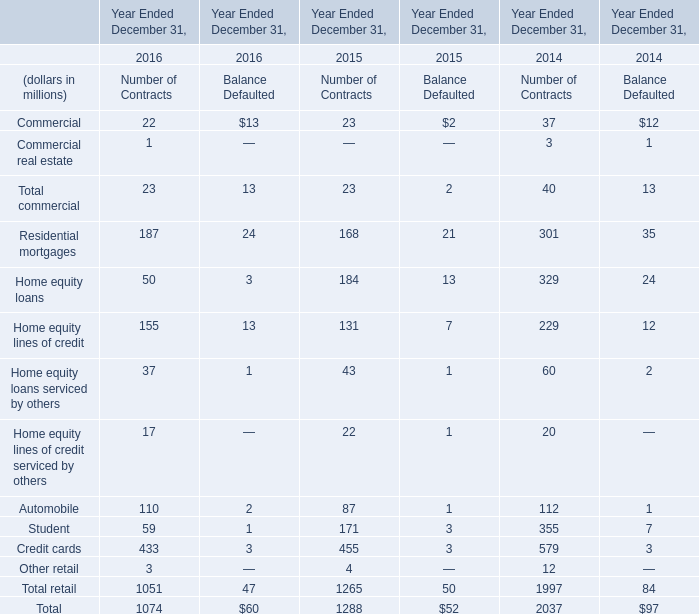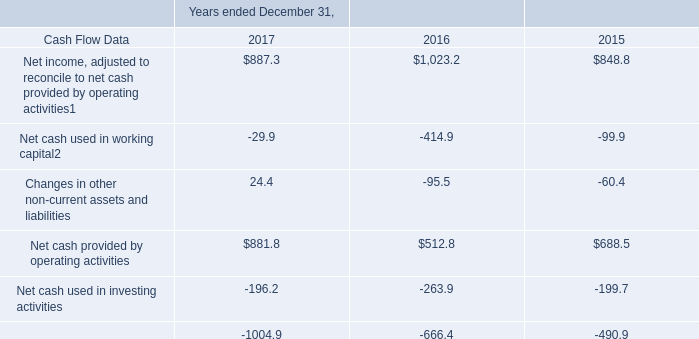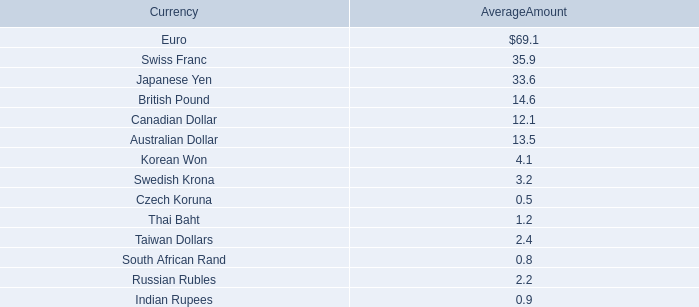Is the total amount of all elements in 2015 greater than that in 2016? 
Answer: yes. What will commercial be like in 2017 if it develops with the same increasing rate as current? (in million) 
Computations: (((((22 + 13) - (23 + 2)) / (22 + 13)) * (22 + 13)) + (22 + 13))
Answer: 45.0. 